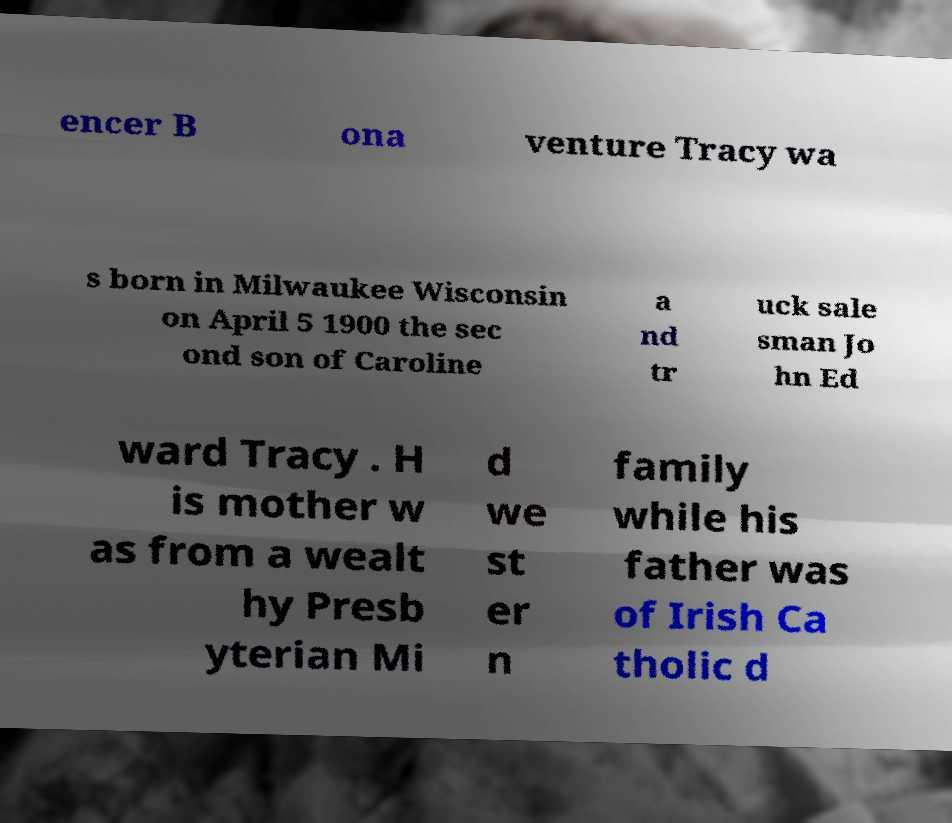Can you read and provide the text displayed in the image?This photo seems to have some interesting text. Can you extract and type it out for me? encer B ona venture Tracy wa s born in Milwaukee Wisconsin on April 5 1900 the sec ond son of Caroline a nd tr uck sale sman Jo hn Ed ward Tracy . H is mother w as from a wealt hy Presb yterian Mi d we st er n family while his father was of Irish Ca tholic d 